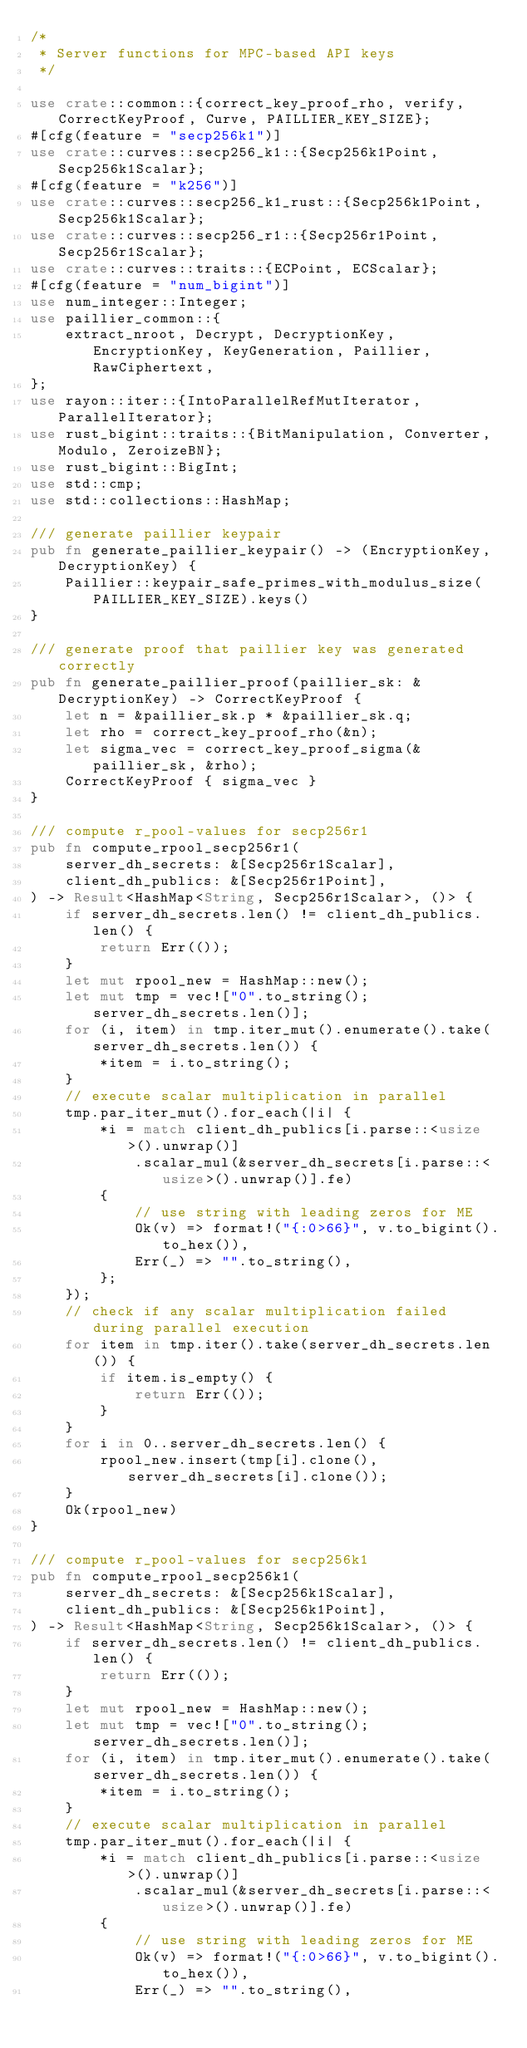<code> <loc_0><loc_0><loc_500><loc_500><_Rust_>/*
 * Server functions for MPC-based API keys
 */

use crate::common::{correct_key_proof_rho, verify, CorrectKeyProof, Curve, PAILLIER_KEY_SIZE};
#[cfg(feature = "secp256k1")]
use crate::curves::secp256_k1::{Secp256k1Point, Secp256k1Scalar};
#[cfg(feature = "k256")]
use crate::curves::secp256_k1_rust::{Secp256k1Point, Secp256k1Scalar};
use crate::curves::secp256_r1::{Secp256r1Point, Secp256r1Scalar};
use crate::curves::traits::{ECPoint, ECScalar};
#[cfg(feature = "num_bigint")]
use num_integer::Integer;
use paillier_common::{
    extract_nroot, Decrypt, DecryptionKey, EncryptionKey, KeyGeneration, Paillier, RawCiphertext,
};
use rayon::iter::{IntoParallelRefMutIterator, ParallelIterator};
use rust_bigint::traits::{BitManipulation, Converter, Modulo, ZeroizeBN};
use rust_bigint::BigInt;
use std::cmp;
use std::collections::HashMap;

/// generate paillier keypair
pub fn generate_paillier_keypair() -> (EncryptionKey, DecryptionKey) {
    Paillier::keypair_safe_primes_with_modulus_size(PAILLIER_KEY_SIZE).keys()
}

/// generate proof that paillier key was generated correctly
pub fn generate_paillier_proof(paillier_sk: &DecryptionKey) -> CorrectKeyProof {
    let n = &paillier_sk.p * &paillier_sk.q;
    let rho = correct_key_proof_rho(&n);
    let sigma_vec = correct_key_proof_sigma(&paillier_sk, &rho);
    CorrectKeyProof { sigma_vec }
}

/// compute r_pool-values for secp256r1
pub fn compute_rpool_secp256r1(
    server_dh_secrets: &[Secp256r1Scalar],
    client_dh_publics: &[Secp256r1Point],
) -> Result<HashMap<String, Secp256r1Scalar>, ()> {
    if server_dh_secrets.len() != client_dh_publics.len() {
        return Err(());
    }
    let mut rpool_new = HashMap::new();
    let mut tmp = vec!["0".to_string(); server_dh_secrets.len()];
    for (i, item) in tmp.iter_mut().enumerate().take(server_dh_secrets.len()) {
        *item = i.to_string();
    }
    // execute scalar multiplication in parallel
    tmp.par_iter_mut().for_each(|i| {
        *i = match client_dh_publics[i.parse::<usize>().unwrap()]
            .scalar_mul(&server_dh_secrets[i.parse::<usize>().unwrap()].fe)
        {
            // use string with leading zeros for ME
            Ok(v) => format!("{:0>66}", v.to_bigint().to_hex()),
            Err(_) => "".to_string(),
        };
    });
    // check if any scalar multiplication failed during parallel execution
    for item in tmp.iter().take(server_dh_secrets.len()) {
        if item.is_empty() {
            return Err(());
        }
    }
    for i in 0..server_dh_secrets.len() {
        rpool_new.insert(tmp[i].clone(), server_dh_secrets[i].clone());
    }
    Ok(rpool_new)
}

/// compute r_pool-values for secp256k1
pub fn compute_rpool_secp256k1(
    server_dh_secrets: &[Secp256k1Scalar],
    client_dh_publics: &[Secp256k1Point],
) -> Result<HashMap<String, Secp256k1Scalar>, ()> {
    if server_dh_secrets.len() != client_dh_publics.len() {
        return Err(());
    }
    let mut rpool_new = HashMap::new();
    let mut tmp = vec!["0".to_string(); server_dh_secrets.len()];
    for (i, item) in tmp.iter_mut().enumerate().take(server_dh_secrets.len()) {
        *item = i.to_string();
    }
    // execute scalar multiplication in parallel
    tmp.par_iter_mut().for_each(|i| {
        *i = match client_dh_publics[i.parse::<usize>().unwrap()]
            .scalar_mul(&server_dh_secrets[i.parse::<usize>().unwrap()].fe)
        {
            // use string with leading zeros for ME
            Ok(v) => format!("{:0>66}", v.to_bigint().to_hex()),
            Err(_) => "".to_string(),</code> 